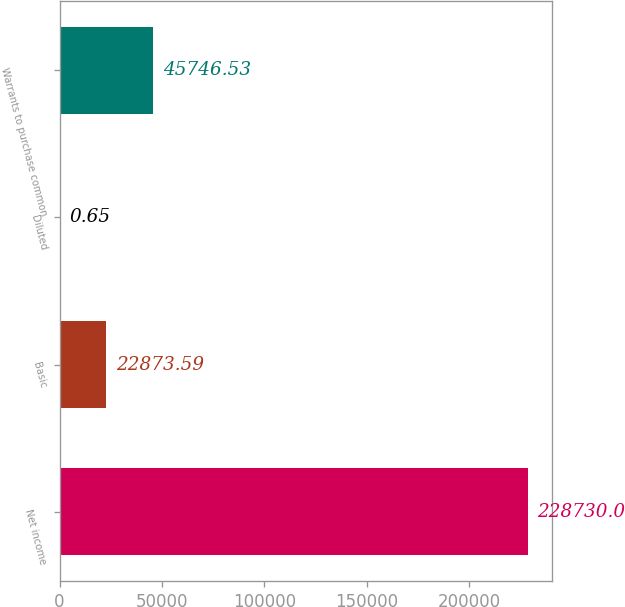Convert chart to OTSL. <chart><loc_0><loc_0><loc_500><loc_500><bar_chart><fcel>Net income<fcel>Basic<fcel>Diluted<fcel>Warrants to purchase common<nl><fcel>228730<fcel>22873.6<fcel>0.65<fcel>45746.5<nl></chart> 